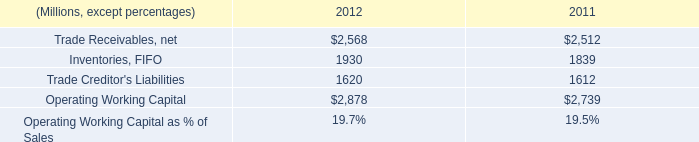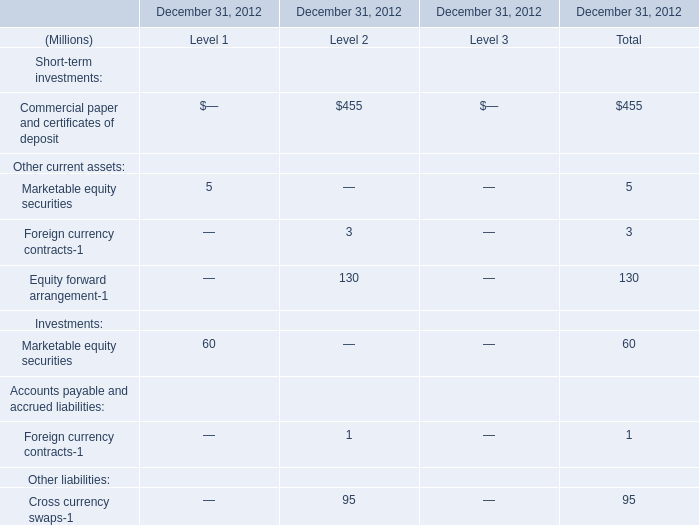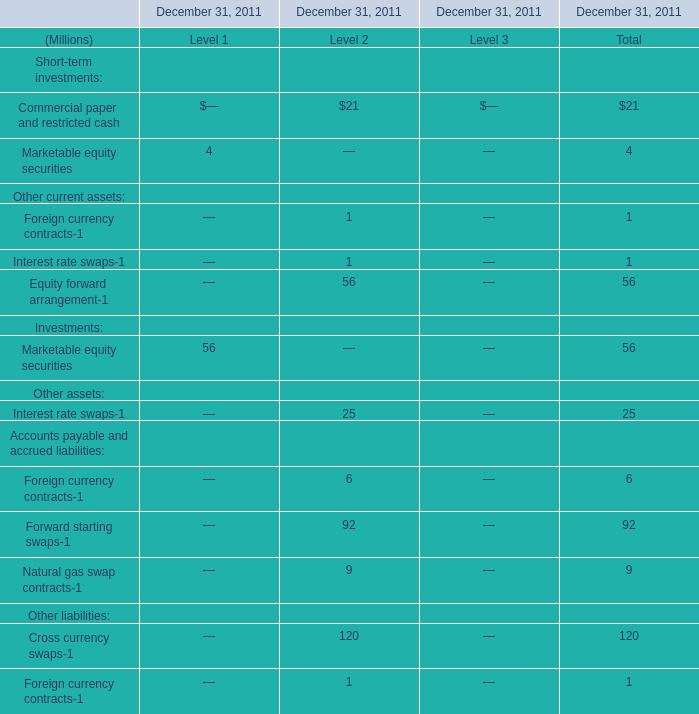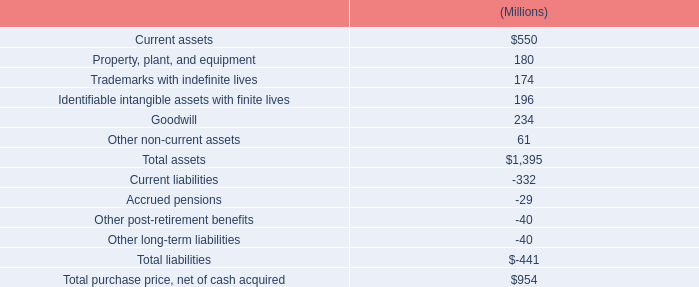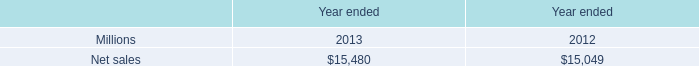What's the average of Inventories, FIFO of 2012, and Net sales of Year ended 2013 ? 
Computations: ((1930.0 + 15480.0) / 2)
Answer: 8705.0. 